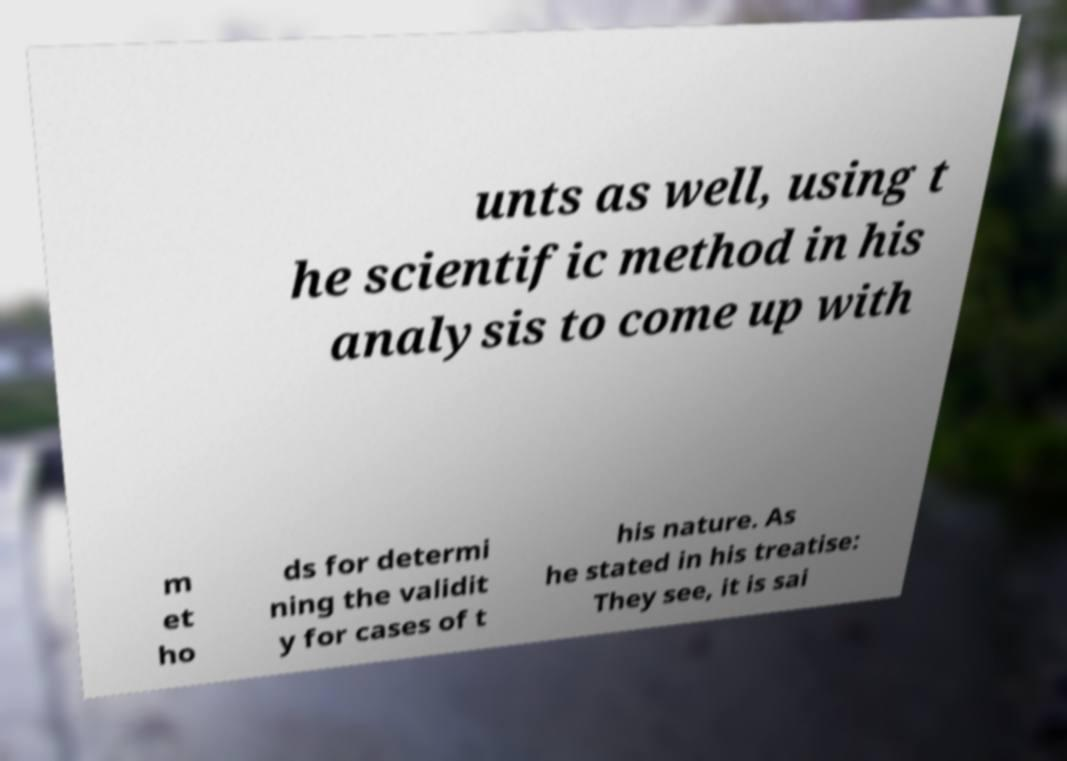For documentation purposes, I need the text within this image transcribed. Could you provide that? unts as well, using t he scientific method in his analysis to come up with m et ho ds for determi ning the validit y for cases of t his nature. As he stated in his treatise: They see, it is sai 